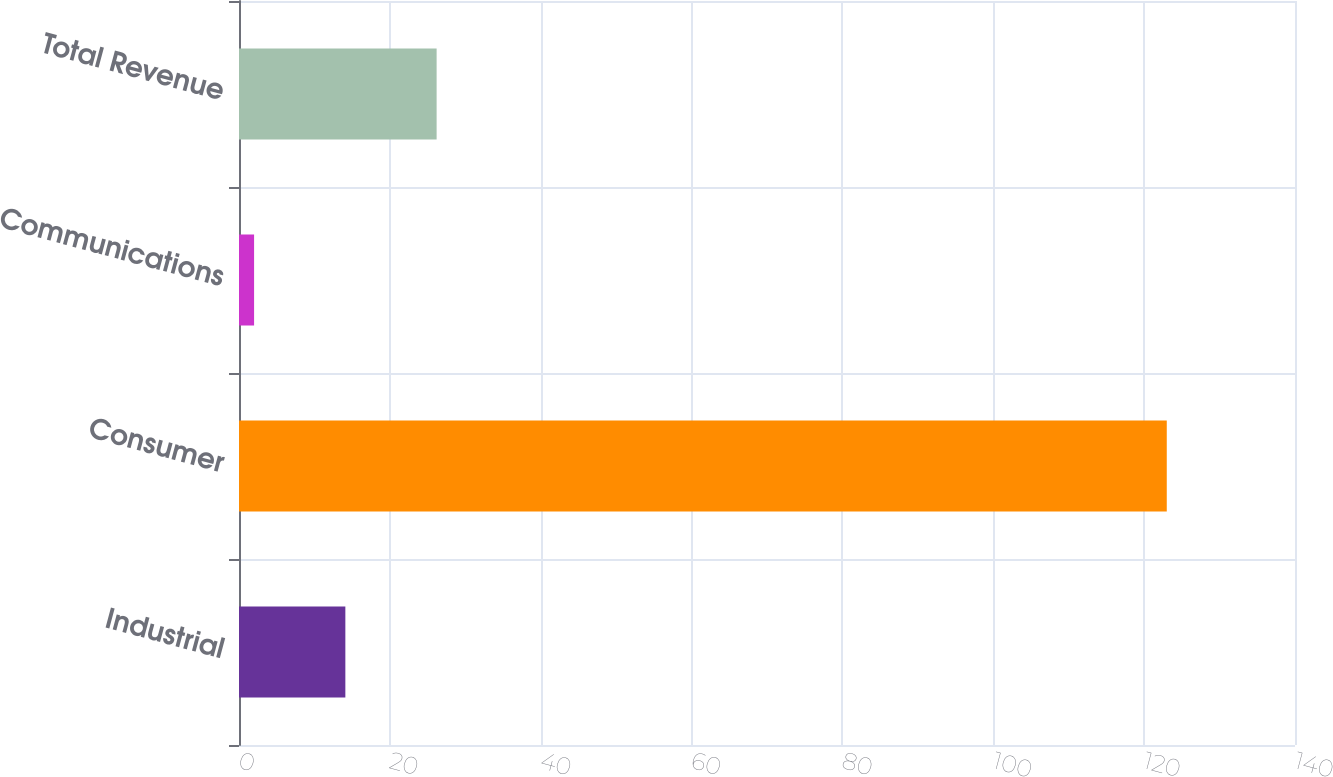<chart> <loc_0><loc_0><loc_500><loc_500><bar_chart><fcel>Industrial<fcel>Consumer<fcel>Communications<fcel>Total Revenue<nl><fcel>14.1<fcel>123<fcel>2<fcel>26.2<nl></chart> 